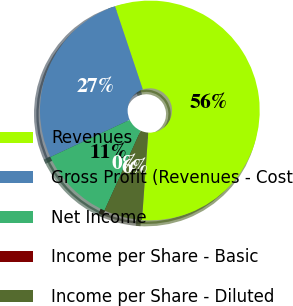<chart> <loc_0><loc_0><loc_500><loc_500><pie_chart><fcel>Revenues<fcel>Gross Profit (Revenues - Cost<fcel>Net Income<fcel>Income per Share - Basic<fcel>Income per Share - Diluted<nl><fcel>56.28%<fcel>26.83%<fcel>11.26%<fcel>0.0%<fcel>5.63%<nl></chart> 